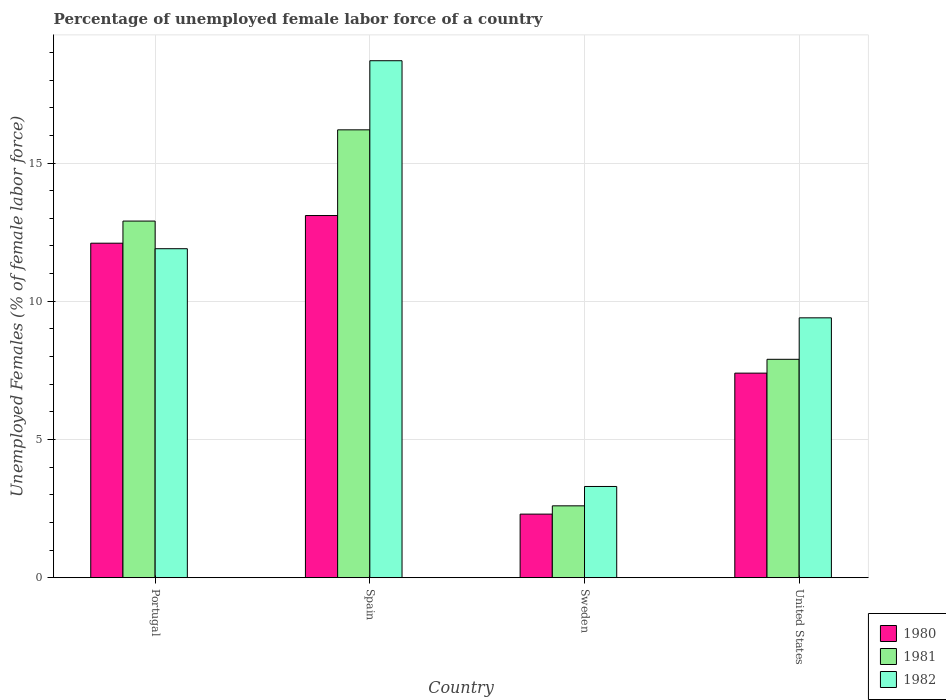How many bars are there on the 1st tick from the left?
Your answer should be compact. 3. How many bars are there on the 2nd tick from the right?
Your answer should be very brief. 3. What is the percentage of unemployed female labor force in 1982 in Spain?
Provide a succinct answer. 18.7. Across all countries, what is the maximum percentage of unemployed female labor force in 1981?
Offer a very short reply. 16.2. Across all countries, what is the minimum percentage of unemployed female labor force in 1980?
Provide a succinct answer. 2.3. In which country was the percentage of unemployed female labor force in 1980 maximum?
Your answer should be very brief. Spain. What is the total percentage of unemployed female labor force in 1981 in the graph?
Your response must be concise. 39.6. What is the difference between the percentage of unemployed female labor force in 1981 in Portugal and that in Spain?
Ensure brevity in your answer.  -3.3. What is the difference between the percentage of unemployed female labor force in 1982 in Sweden and the percentage of unemployed female labor force in 1980 in Spain?
Offer a terse response. -9.8. What is the average percentage of unemployed female labor force in 1981 per country?
Offer a very short reply. 9.9. What is the difference between the percentage of unemployed female labor force of/in 1981 and percentage of unemployed female labor force of/in 1982 in Spain?
Your answer should be very brief. -2.5. What is the ratio of the percentage of unemployed female labor force in 1981 in Portugal to that in United States?
Ensure brevity in your answer.  1.63. Is the percentage of unemployed female labor force in 1980 in Spain less than that in United States?
Offer a very short reply. No. What is the difference between the highest and the lowest percentage of unemployed female labor force in 1980?
Your answer should be compact. 10.8. In how many countries, is the percentage of unemployed female labor force in 1981 greater than the average percentage of unemployed female labor force in 1981 taken over all countries?
Your answer should be compact. 2. What does the 2nd bar from the right in Sweden represents?
Offer a terse response. 1981. Is it the case that in every country, the sum of the percentage of unemployed female labor force in 1982 and percentage of unemployed female labor force in 1981 is greater than the percentage of unemployed female labor force in 1980?
Your answer should be very brief. Yes. How many bars are there?
Your answer should be compact. 12. Are all the bars in the graph horizontal?
Offer a terse response. No. How many countries are there in the graph?
Give a very brief answer. 4. Does the graph contain any zero values?
Your answer should be very brief. No. Where does the legend appear in the graph?
Your answer should be compact. Bottom right. How many legend labels are there?
Keep it short and to the point. 3. How are the legend labels stacked?
Offer a very short reply. Vertical. What is the title of the graph?
Make the answer very short. Percentage of unemployed female labor force of a country. What is the label or title of the X-axis?
Make the answer very short. Country. What is the label or title of the Y-axis?
Your answer should be very brief. Unemployed Females (% of female labor force). What is the Unemployed Females (% of female labor force) in 1980 in Portugal?
Offer a terse response. 12.1. What is the Unemployed Females (% of female labor force) in 1981 in Portugal?
Give a very brief answer. 12.9. What is the Unemployed Females (% of female labor force) in 1982 in Portugal?
Provide a short and direct response. 11.9. What is the Unemployed Females (% of female labor force) in 1980 in Spain?
Offer a very short reply. 13.1. What is the Unemployed Females (% of female labor force) in 1981 in Spain?
Keep it short and to the point. 16.2. What is the Unemployed Females (% of female labor force) in 1982 in Spain?
Your answer should be very brief. 18.7. What is the Unemployed Females (% of female labor force) in 1980 in Sweden?
Make the answer very short. 2.3. What is the Unemployed Females (% of female labor force) of 1981 in Sweden?
Keep it short and to the point. 2.6. What is the Unemployed Females (% of female labor force) of 1982 in Sweden?
Your response must be concise. 3.3. What is the Unemployed Females (% of female labor force) of 1980 in United States?
Make the answer very short. 7.4. What is the Unemployed Females (% of female labor force) in 1981 in United States?
Provide a succinct answer. 7.9. What is the Unemployed Females (% of female labor force) of 1982 in United States?
Your answer should be compact. 9.4. Across all countries, what is the maximum Unemployed Females (% of female labor force) in 1980?
Make the answer very short. 13.1. Across all countries, what is the maximum Unemployed Females (% of female labor force) in 1981?
Offer a very short reply. 16.2. Across all countries, what is the maximum Unemployed Females (% of female labor force) in 1982?
Make the answer very short. 18.7. Across all countries, what is the minimum Unemployed Females (% of female labor force) in 1980?
Your answer should be compact. 2.3. Across all countries, what is the minimum Unemployed Females (% of female labor force) of 1981?
Keep it short and to the point. 2.6. Across all countries, what is the minimum Unemployed Females (% of female labor force) of 1982?
Provide a short and direct response. 3.3. What is the total Unemployed Females (% of female labor force) of 1980 in the graph?
Offer a terse response. 34.9. What is the total Unemployed Females (% of female labor force) in 1981 in the graph?
Your response must be concise. 39.6. What is the total Unemployed Females (% of female labor force) in 1982 in the graph?
Your response must be concise. 43.3. What is the difference between the Unemployed Females (% of female labor force) in 1981 in Portugal and that in Sweden?
Your answer should be compact. 10.3. What is the difference between the Unemployed Females (% of female labor force) of 1982 in Portugal and that in Sweden?
Keep it short and to the point. 8.6. What is the difference between the Unemployed Females (% of female labor force) in 1980 in Spain and that in Sweden?
Offer a very short reply. 10.8. What is the difference between the Unemployed Females (% of female labor force) in 1982 in Spain and that in Sweden?
Offer a very short reply. 15.4. What is the difference between the Unemployed Females (% of female labor force) of 1980 in Spain and that in United States?
Provide a succinct answer. 5.7. What is the difference between the Unemployed Females (% of female labor force) of 1982 in Spain and that in United States?
Ensure brevity in your answer.  9.3. What is the difference between the Unemployed Females (% of female labor force) in 1981 in Sweden and that in United States?
Provide a short and direct response. -5.3. What is the difference between the Unemployed Females (% of female labor force) in 1980 in Portugal and the Unemployed Females (% of female labor force) in 1981 in Spain?
Offer a very short reply. -4.1. What is the difference between the Unemployed Females (% of female labor force) in 1980 in Portugal and the Unemployed Females (% of female labor force) in 1982 in Spain?
Your response must be concise. -6.6. What is the difference between the Unemployed Females (% of female labor force) in 1981 in Portugal and the Unemployed Females (% of female labor force) in 1982 in Spain?
Your answer should be compact. -5.8. What is the difference between the Unemployed Females (% of female labor force) in 1980 in Portugal and the Unemployed Females (% of female labor force) in 1981 in Sweden?
Make the answer very short. 9.5. What is the difference between the Unemployed Females (% of female labor force) of 1980 in Portugal and the Unemployed Females (% of female labor force) of 1981 in United States?
Keep it short and to the point. 4.2. What is the difference between the Unemployed Females (% of female labor force) in 1980 in Portugal and the Unemployed Females (% of female labor force) in 1982 in United States?
Give a very brief answer. 2.7. What is the difference between the Unemployed Females (% of female labor force) in 1980 in Spain and the Unemployed Females (% of female labor force) in 1981 in Sweden?
Offer a very short reply. 10.5. What is the difference between the Unemployed Females (% of female labor force) of 1980 in Spain and the Unemployed Females (% of female labor force) of 1982 in Sweden?
Make the answer very short. 9.8. What is the difference between the Unemployed Females (% of female labor force) in 1981 in Spain and the Unemployed Females (% of female labor force) in 1982 in Sweden?
Your answer should be compact. 12.9. What is the difference between the Unemployed Females (% of female labor force) in 1980 in Spain and the Unemployed Females (% of female labor force) in 1982 in United States?
Provide a short and direct response. 3.7. What is the difference between the Unemployed Females (% of female labor force) of 1981 in Sweden and the Unemployed Females (% of female labor force) of 1982 in United States?
Give a very brief answer. -6.8. What is the average Unemployed Females (% of female labor force) of 1980 per country?
Ensure brevity in your answer.  8.72. What is the average Unemployed Females (% of female labor force) in 1982 per country?
Provide a succinct answer. 10.82. What is the difference between the Unemployed Females (% of female labor force) in 1980 and Unemployed Females (% of female labor force) in 1982 in Portugal?
Your response must be concise. 0.2. What is the difference between the Unemployed Females (% of female labor force) of 1981 and Unemployed Females (% of female labor force) of 1982 in Portugal?
Ensure brevity in your answer.  1. What is the difference between the Unemployed Females (% of female labor force) of 1980 and Unemployed Females (% of female labor force) of 1982 in Sweden?
Your answer should be compact. -1. What is the difference between the Unemployed Females (% of female labor force) in 1981 and Unemployed Females (% of female labor force) in 1982 in Sweden?
Give a very brief answer. -0.7. What is the difference between the Unemployed Females (% of female labor force) in 1980 and Unemployed Females (% of female labor force) in 1981 in United States?
Your answer should be very brief. -0.5. What is the ratio of the Unemployed Females (% of female labor force) in 1980 in Portugal to that in Spain?
Offer a terse response. 0.92. What is the ratio of the Unemployed Females (% of female labor force) in 1981 in Portugal to that in Spain?
Give a very brief answer. 0.8. What is the ratio of the Unemployed Females (% of female labor force) of 1982 in Portugal to that in Spain?
Make the answer very short. 0.64. What is the ratio of the Unemployed Females (% of female labor force) of 1980 in Portugal to that in Sweden?
Offer a very short reply. 5.26. What is the ratio of the Unemployed Females (% of female labor force) in 1981 in Portugal to that in Sweden?
Ensure brevity in your answer.  4.96. What is the ratio of the Unemployed Females (% of female labor force) of 1982 in Portugal to that in Sweden?
Give a very brief answer. 3.61. What is the ratio of the Unemployed Females (% of female labor force) in 1980 in Portugal to that in United States?
Give a very brief answer. 1.64. What is the ratio of the Unemployed Females (% of female labor force) in 1981 in Portugal to that in United States?
Provide a succinct answer. 1.63. What is the ratio of the Unemployed Females (% of female labor force) of 1982 in Portugal to that in United States?
Your response must be concise. 1.27. What is the ratio of the Unemployed Females (% of female labor force) in 1980 in Spain to that in Sweden?
Give a very brief answer. 5.7. What is the ratio of the Unemployed Females (% of female labor force) of 1981 in Spain to that in Sweden?
Provide a succinct answer. 6.23. What is the ratio of the Unemployed Females (% of female labor force) in 1982 in Spain to that in Sweden?
Provide a succinct answer. 5.67. What is the ratio of the Unemployed Females (% of female labor force) in 1980 in Spain to that in United States?
Offer a terse response. 1.77. What is the ratio of the Unemployed Females (% of female labor force) of 1981 in Spain to that in United States?
Offer a terse response. 2.05. What is the ratio of the Unemployed Females (% of female labor force) of 1982 in Spain to that in United States?
Make the answer very short. 1.99. What is the ratio of the Unemployed Females (% of female labor force) in 1980 in Sweden to that in United States?
Your answer should be very brief. 0.31. What is the ratio of the Unemployed Females (% of female labor force) of 1981 in Sweden to that in United States?
Ensure brevity in your answer.  0.33. What is the ratio of the Unemployed Females (% of female labor force) of 1982 in Sweden to that in United States?
Your response must be concise. 0.35. What is the difference between the highest and the second highest Unemployed Females (% of female labor force) in 1980?
Make the answer very short. 1. What is the difference between the highest and the second highest Unemployed Females (% of female labor force) of 1981?
Give a very brief answer. 3.3. What is the difference between the highest and the lowest Unemployed Females (% of female labor force) of 1980?
Your response must be concise. 10.8. 